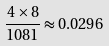<formula> <loc_0><loc_0><loc_500><loc_500>\frac { 4 \times 8 } { 1 0 8 1 } \approx 0 . 0 2 9 6</formula> 